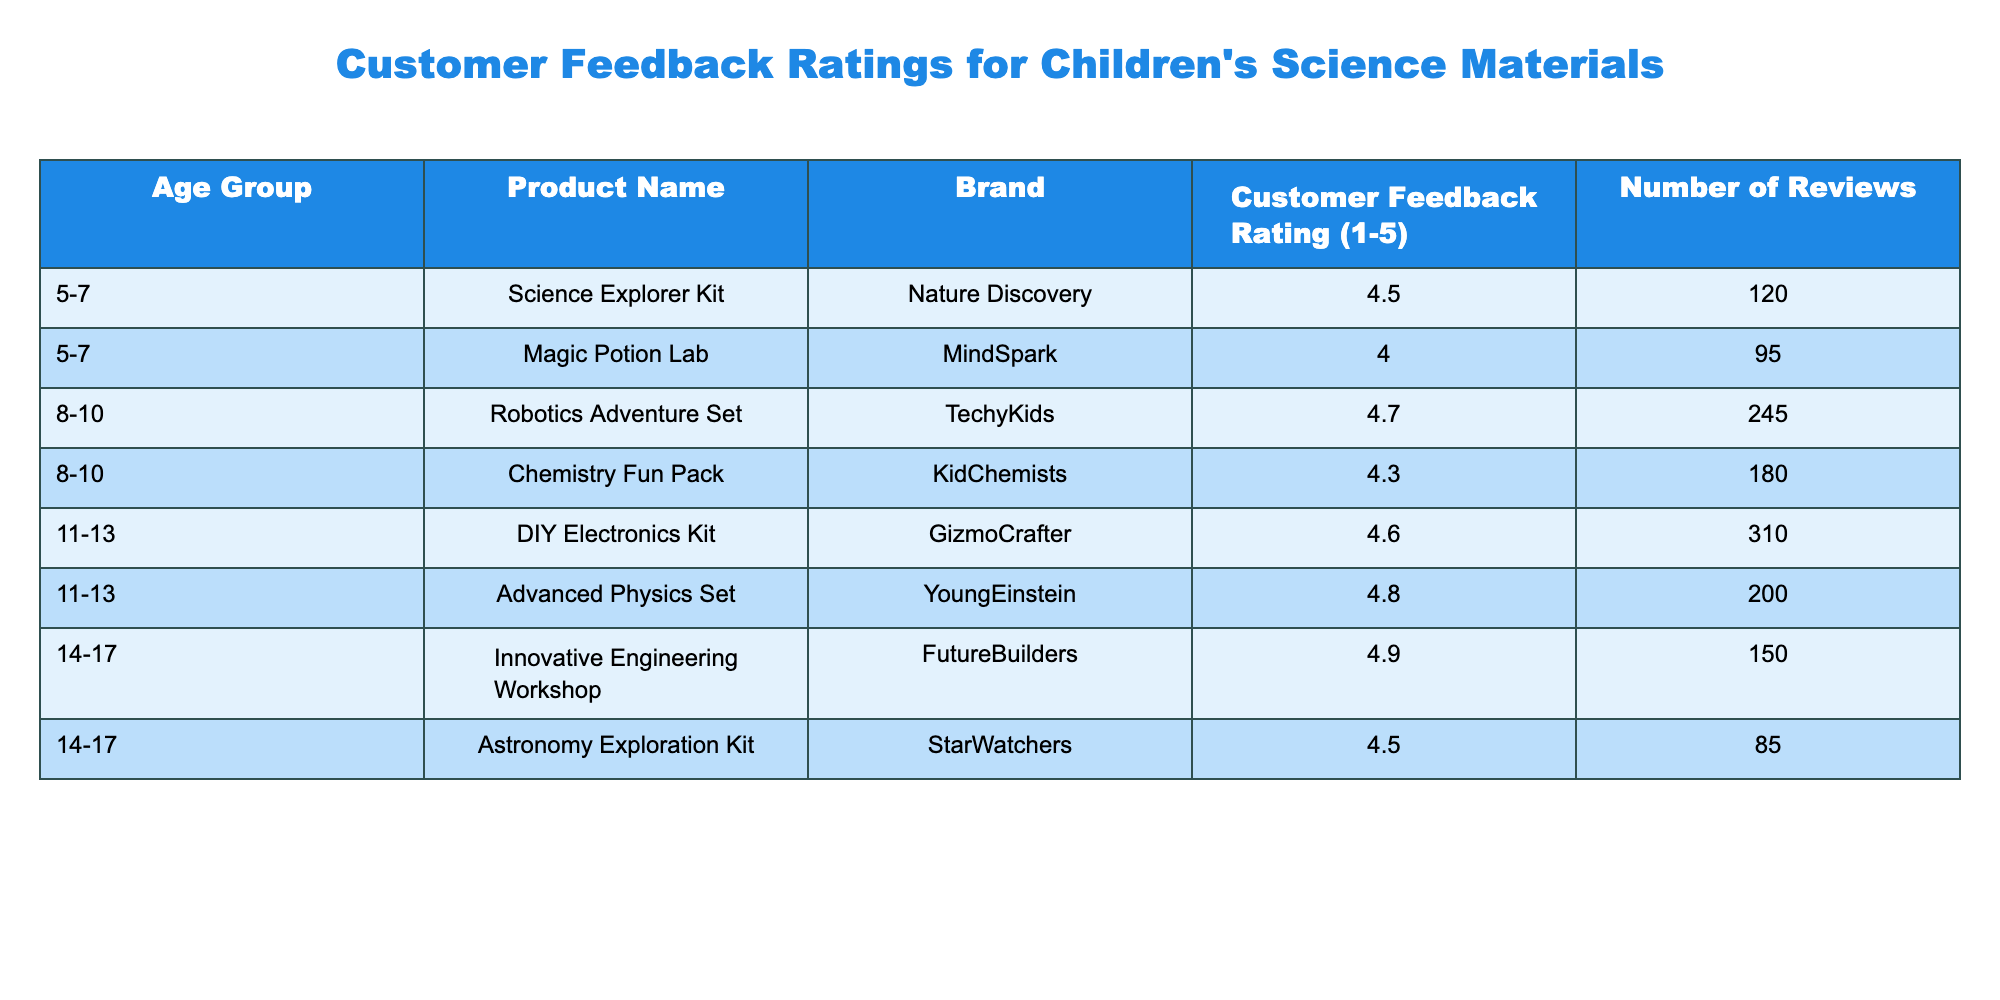What is the highest customer feedback rating among all products? By inspecting the table, we see that the highest customer feedback rating is 4.9 for the "Innovative Engineering Workshop" in the 14-17 age group.
Answer: 4.9 Which product received the lowest customer feedback rating? The product with the lowest feedback rating is the "Magic Potion Lab" with a rating of 4.0 in the 5-7 age group.
Answer: 4.0 How many reviews did the "DIY Electronics Kit" receive? According to the table, the "DIY Electronics Kit" received 310 reviews.
Answer: 310 What is the average customer feedback rating for products aimed at 8-10-year-olds? To find the average rating for the 8-10 age group, we sum the ratings (4.7 + 4.3 = 9.0) and divide by the number of products (2). The average rating is 9.0 / 2 = 4.5.
Answer: 4.5 Is the customer feedback rating for the "Astronomy Exploration Kit" higher than 4.7? The rating for the "Astronomy Exploration Kit" is 4.5, which is less than 4.7, making the statement false.
Answer: No How many products are rated above 4.5? By reviewing the ratings, four products have ratings above 4.5: "Robotics Adventure Set" (4.7), "DIY Electronics Kit" (4.6), "Advanced Physics Set" (4.8), and "Innovative Engineering Workshop" (4.9), totaling four products.
Answer: 4 Which brand has the most reviewed product in the 11-13 age group? In the 11-13 age group, the "DIY Electronics Kit" by GizmoCrafter has the most reviews (310), compared to the "Advanced Physics Set" by YoungEinstein (200).
Answer: GizmoCrafter What is the difference in customer feedback ratings between the highest-rated product in the 14-17 age group and the lowest-rated product in the same group? The highest-rated product in the 14-17 age group is the "Innovative Engineering Workshop" at 4.9, and the lowest is the "Astronomy Exploration Kit" at 4.5. The difference is 4.9 - 4.5 = 0.4.
Answer: 0.4 Are there more products rated at 4.5 or lower than there are products rated above 4.5? There are two products rated 4.5 or lower: "Magic Potion Lab" (4.0) and "Astronomy Exploration Kit" (4.5). There are four products rated above 4.5. Since 4 is greater than 2, the statement is true.
Answer: No 